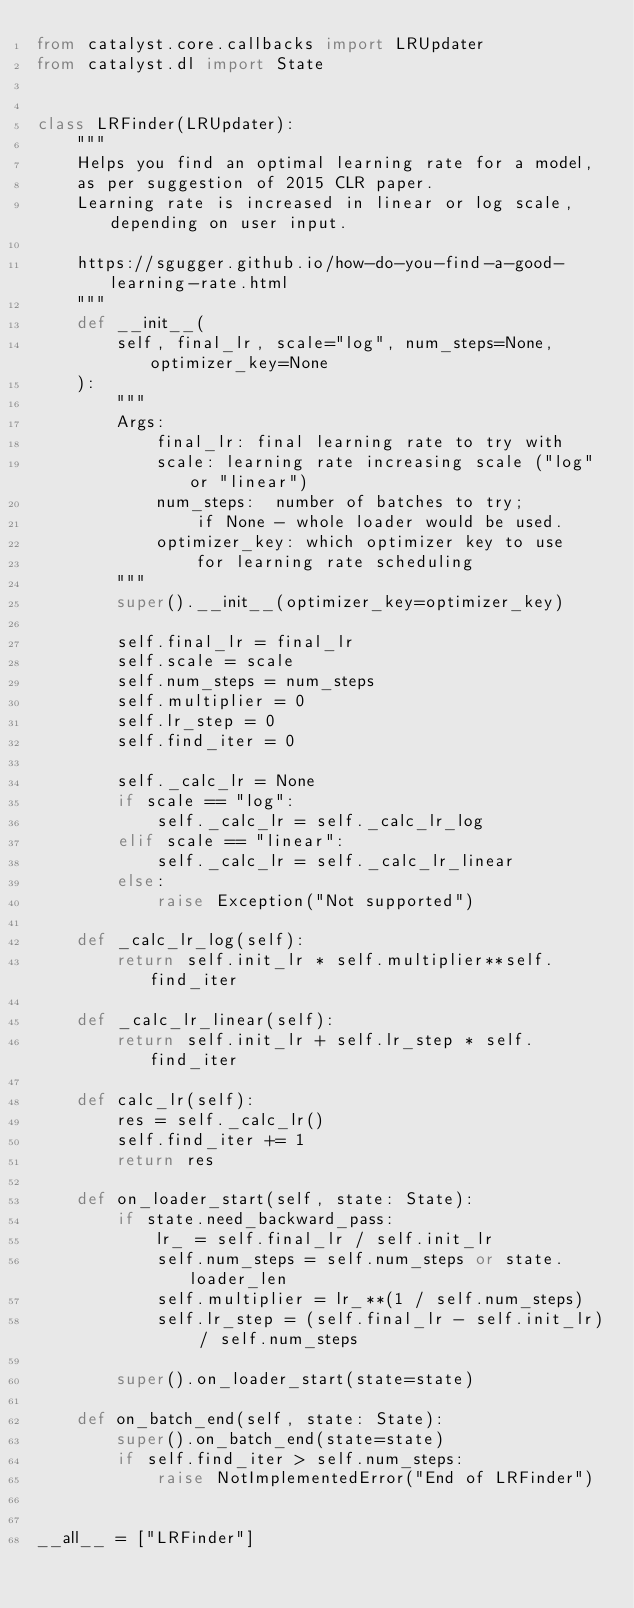Convert code to text. <code><loc_0><loc_0><loc_500><loc_500><_Python_>from catalyst.core.callbacks import LRUpdater
from catalyst.dl import State


class LRFinder(LRUpdater):
    """
    Helps you find an optimal learning rate for a model,
    as per suggestion of 2015 CLR paper.
    Learning rate is increased in linear or log scale, depending on user input.

    https://sgugger.github.io/how-do-you-find-a-good-learning-rate.html
    """
    def __init__(
        self, final_lr, scale="log", num_steps=None, optimizer_key=None
    ):
        """
        Args:
            final_lr: final learning rate to try with
            scale: learning rate increasing scale ("log" or "linear")
            num_steps:  number of batches to try;
                if None - whole loader would be used.
            optimizer_key: which optimizer key to use
                for learning rate scheduling
        """
        super().__init__(optimizer_key=optimizer_key)

        self.final_lr = final_lr
        self.scale = scale
        self.num_steps = num_steps
        self.multiplier = 0
        self.lr_step = 0
        self.find_iter = 0

        self._calc_lr = None
        if scale == "log":
            self._calc_lr = self._calc_lr_log
        elif scale == "linear":
            self._calc_lr = self._calc_lr_linear
        else:
            raise Exception("Not supported")

    def _calc_lr_log(self):
        return self.init_lr * self.multiplier**self.find_iter

    def _calc_lr_linear(self):
        return self.init_lr + self.lr_step * self.find_iter

    def calc_lr(self):
        res = self._calc_lr()
        self.find_iter += 1
        return res

    def on_loader_start(self, state: State):
        if state.need_backward_pass:
            lr_ = self.final_lr / self.init_lr
            self.num_steps = self.num_steps or state.loader_len
            self.multiplier = lr_**(1 / self.num_steps)
            self.lr_step = (self.final_lr - self.init_lr) / self.num_steps

        super().on_loader_start(state=state)

    def on_batch_end(self, state: State):
        super().on_batch_end(state=state)
        if self.find_iter > self.num_steps:
            raise NotImplementedError("End of LRFinder")


__all__ = ["LRFinder"]
</code> 